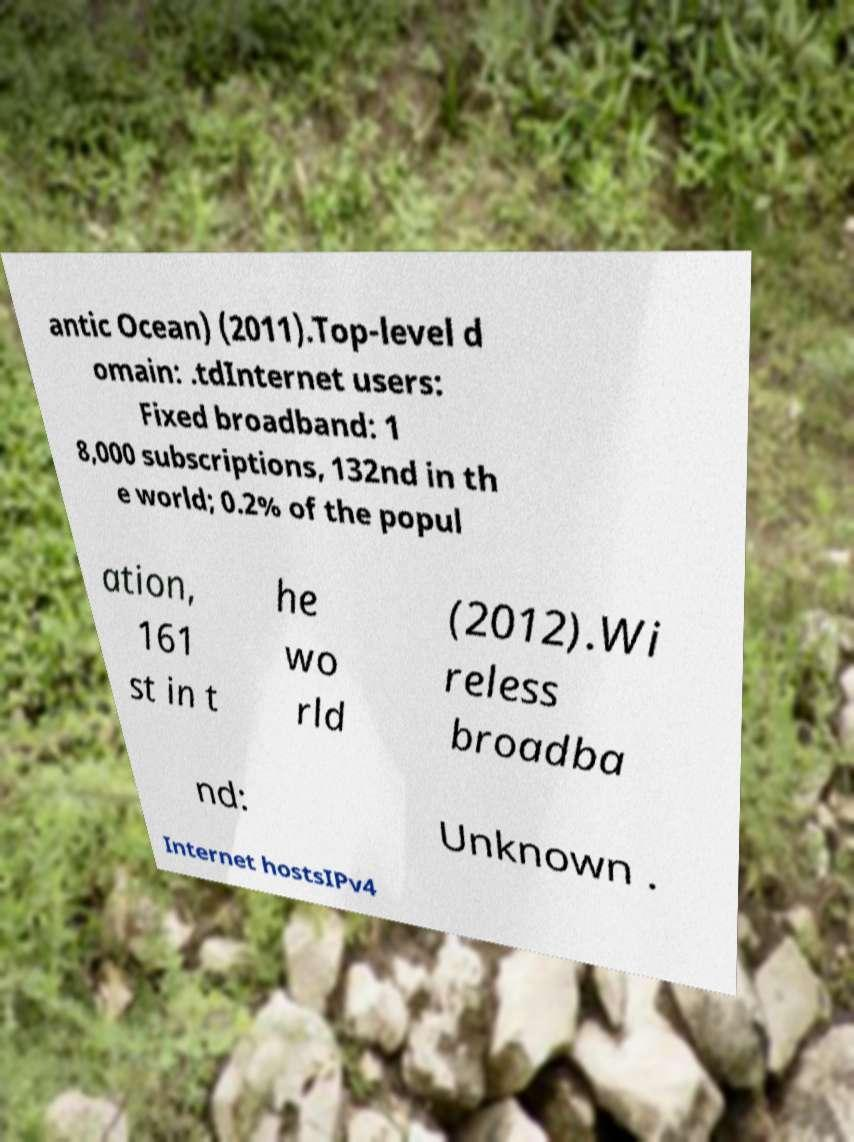Please read and relay the text visible in this image. What does it say? antic Ocean) (2011).Top-level d omain: .tdInternet users: Fixed broadband: 1 8,000 subscriptions, 132nd in th e world; 0.2% of the popul ation, 161 st in t he wo rld (2012).Wi reless broadba nd: Unknown . Internet hostsIPv4 